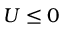Convert formula to latex. <formula><loc_0><loc_0><loc_500><loc_500>U \leq 0</formula> 